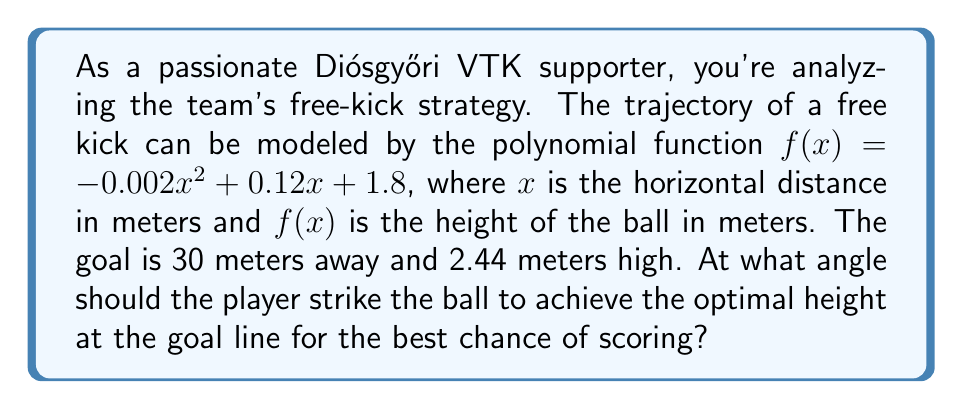Give your solution to this math problem. To solve this problem, we need to follow these steps:

1) First, we need to find the height of the ball at the goal line. We can do this by substituting $x = 30$ into our function:

   $f(30) = -0.002(30)^2 + 0.12(30) + 1.8$
   $= -0.002(900) + 3.6 + 1.8$
   $= -1.8 + 3.6 + 1.8$
   $= 3.6$ meters

2) Now that we know the ball's height at the goal line, we can find the slope of the trajectory at this point. This slope will give us the tangent of the angle we're looking for.

3) To find the slope, we need to take the derivative of our function:

   $f'(x) = -0.004x + 0.12$

4) Now we can find the slope at $x = 30$:

   $f'(30) = -0.004(30) + 0.12 = -0.12 + 0.12 = 0$

5) The slope at the goal line is 0, which means the ball reaches its maximum height exactly at the goal line. This is the optimal trajectory for a free kick.

6) To find the angle, we need to consider the triangle formed by the initial trajectory of the ball. The tangent of this angle is the initial slope of our function.

7) We can find this by evaluating $f'(0)$:

   $f'(0) = -0.004(0) + 0.12 = 0.12$

8) Therefore, $\tan(\theta) = 0.12$

9) We can find $\theta$ by taking the inverse tangent (arctan):

   $\theta = \arctan(0.12) \approx 6.84$ degrees

[asy]
unitsize(5mm);
draw((0,0)--(30,0), arrow=Arrow(TeXHead));
draw((0,0)--(0,4), arrow=Arrow(TeXHead));
draw((0,1.8)..(15,3.6)..(30,3.6), blue);
draw((0,1.8)--(5,2.4), red);
label("$x$", (30,0), S);
label("$y$", (0,4), W);
label("$\theta$", (1,1.9), NW);
dot((30,3.6));
label("(30, 3.6)", (30,3.6), NE);
[/asy]
Answer: The optimal angle for the free kick is approximately 6.84 degrees. 